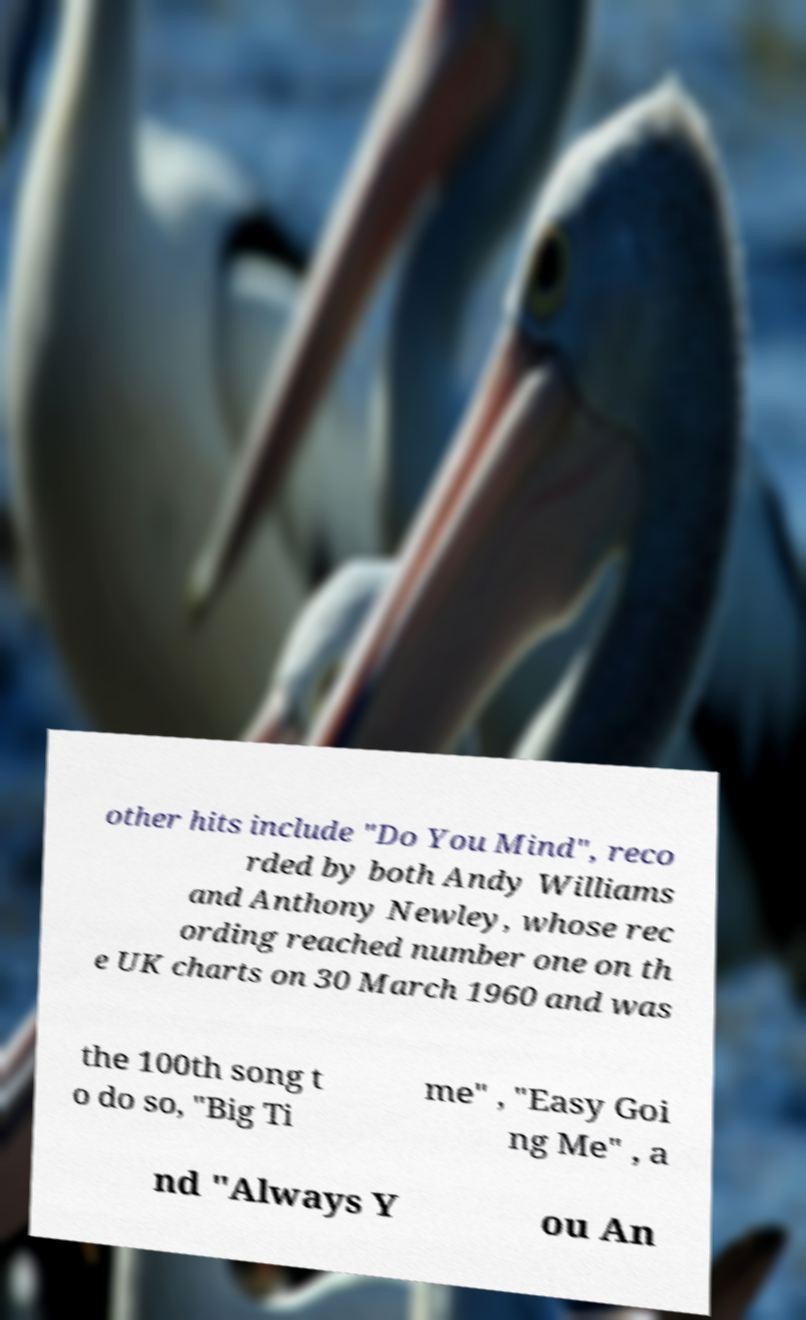Could you extract and type out the text from this image? other hits include "Do You Mind", reco rded by both Andy Williams and Anthony Newley, whose rec ording reached number one on th e UK charts on 30 March 1960 and was the 100th song t o do so, "Big Ti me" , "Easy Goi ng Me" , a nd "Always Y ou An 